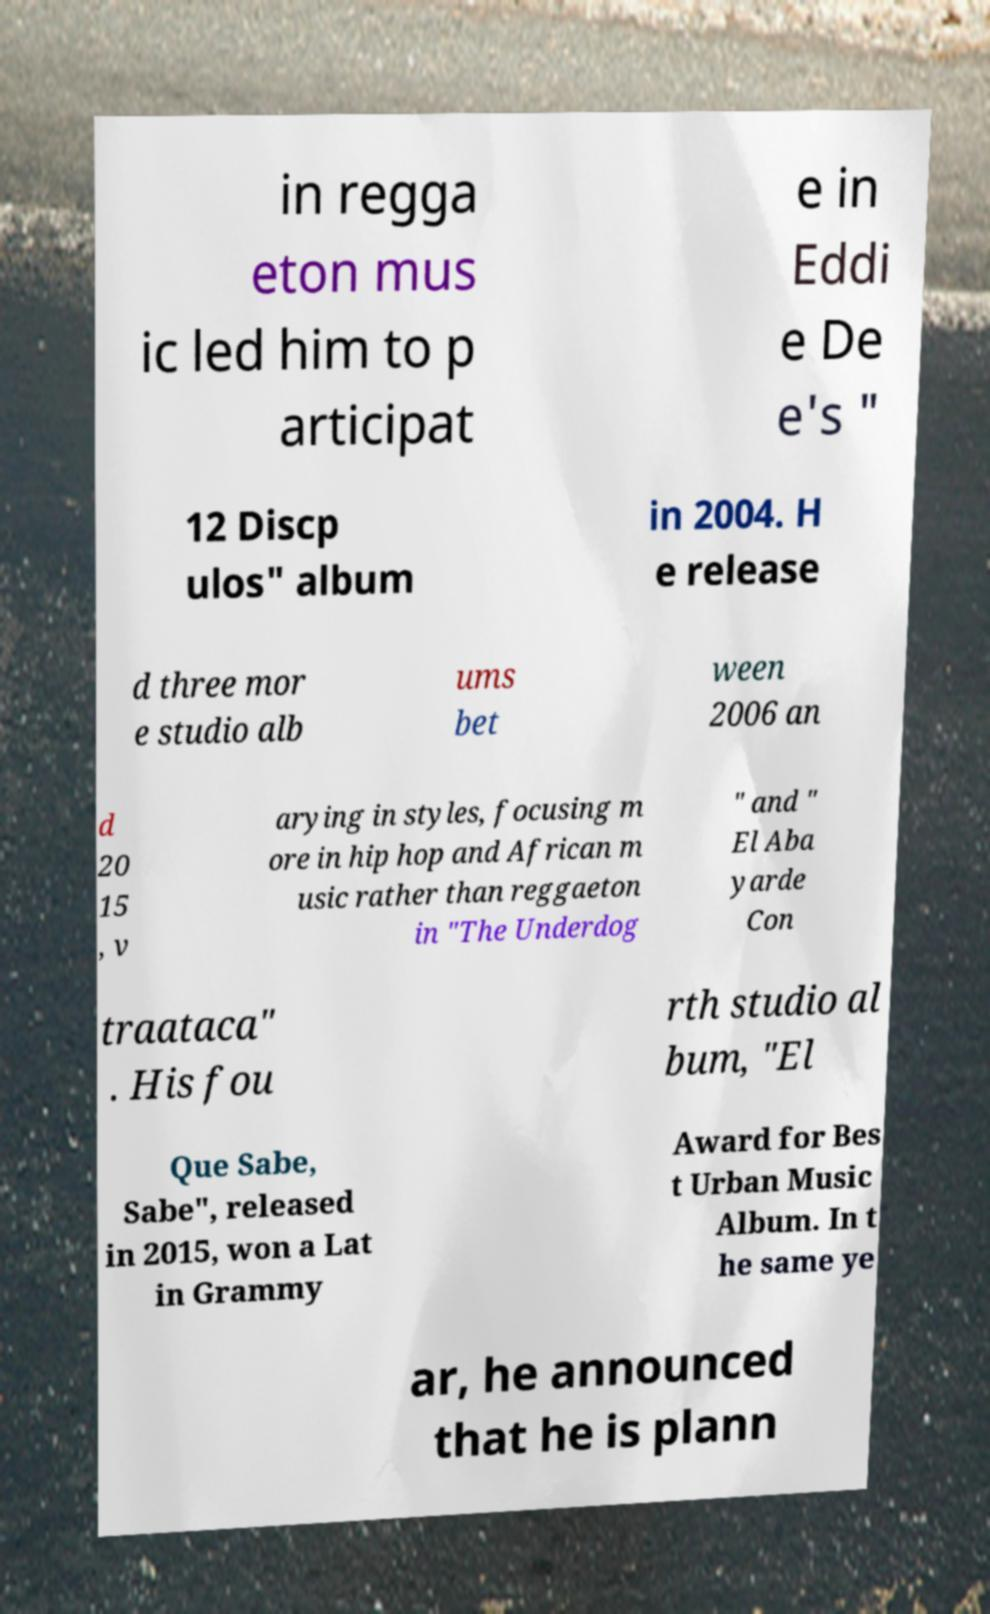For documentation purposes, I need the text within this image transcribed. Could you provide that? in regga eton mus ic led him to p articipat e in Eddi e De e's " 12 Discp ulos" album in 2004. H e release d three mor e studio alb ums bet ween 2006 an d 20 15 , v arying in styles, focusing m ore in hip hop and African m usic rather than reggaeton in "The Underdog " and " El Aba yarde Con traataca" . His fou rth studio al bum, "El Que Sabe, Sabe", released in 2015, won a Lat in Grammy Award for Bes t Urban Music Album. In t he same ye ar, he announced that he is plann 